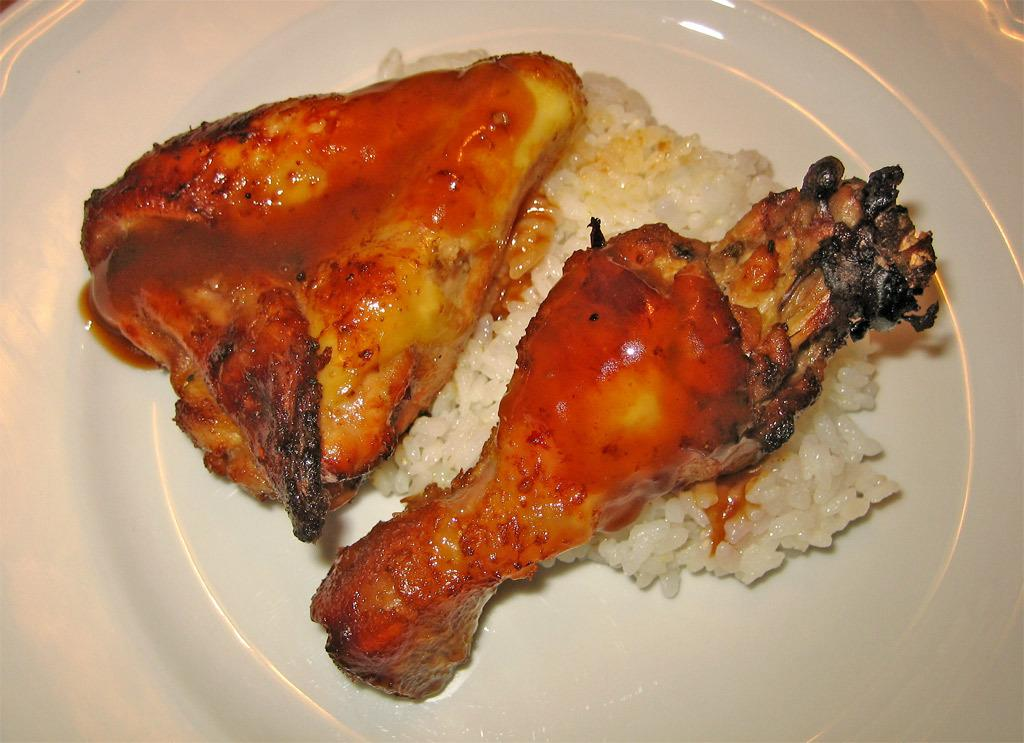What is in the center of the image? There is a plate in the center of the image. What is on the plate? There is food on the plate. Can you identify a specific type of food on the plate? Yes, there is chicken on the plate. What idea does the snow in the image represent? There is no snow present in the image, so it cannot represent any ideas. 